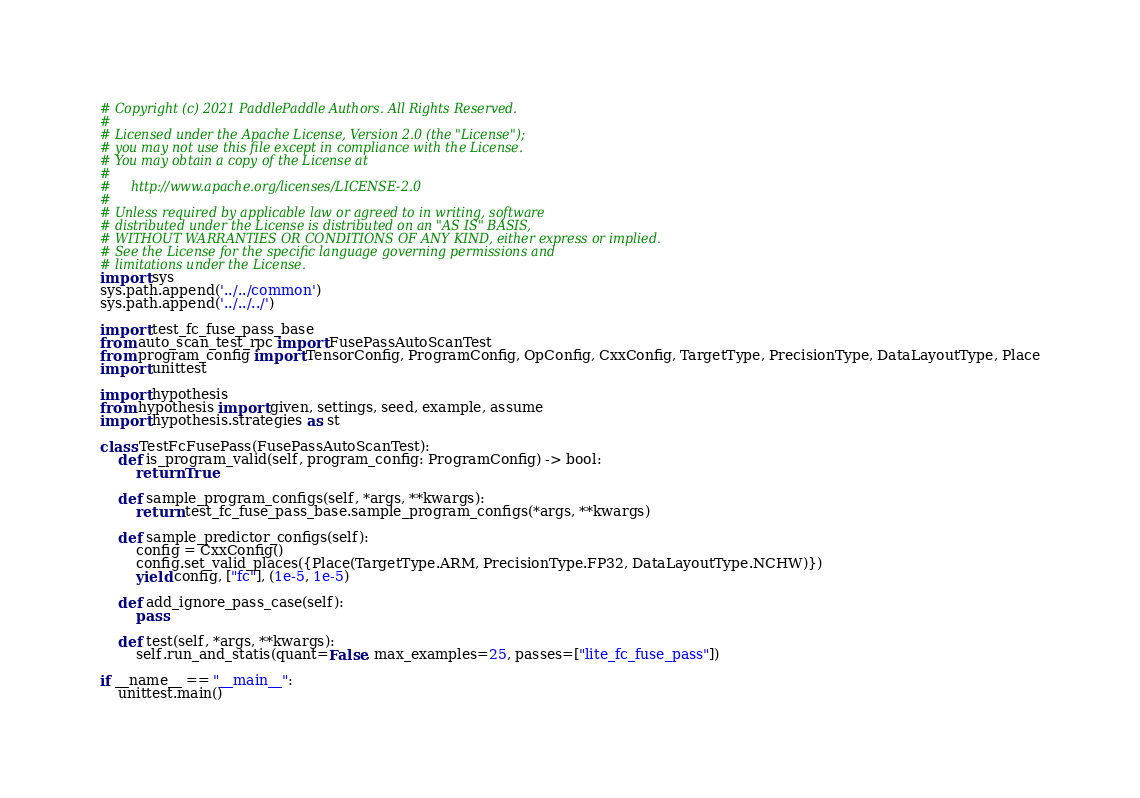Convert code to text. <code><loc_0><loc_0><loc_500><loc_500><_Python_># Copyright (c) 2021 PaddlePaddle Authors. All Rights Reserved.
#
# Licensed under the Apache License, Version 2.0 (the "License");
# you may not use this file except in compliance with the License.
# You may obtain a copy of the License at
#
#     http://www.apache.org/licenses/LICENSE-2.0
#
# Unless required by applicable law or agreed to in writing, software
# distributed under the License is distributed on an "AS IS" BASIS,
# WITHOUT WARRANTIES OR CONDITIONS OF ANY KIND, either express or implied.
# See the License for the specific language governing permissions and
# limitations under the License.
import sys
sys.path.append('../../common')
sys.path.append('../../../')

import test_fc_fuse_pass_base
from auto_scan_test_rpc import FusePassAutoScanTest
from program_config import TensorConfig, ProgramConfig, OpConfig, CxxConfig, TargetType, PrecisionType, DataLayoutType, Place
import unittest

import hypothesis
from hypothesis import given, settings, seed, example, assume
import hypothesis.strategies as st

class TestFcFusePass(FusePassAutoScanTest):
    def is_program_valid(self, program_config: ProgramConfig) -> bool:
        return True

    def sample_program_configs(self, *args, **kwargs):
        return test_fc_fuse_pass_base.sample_program_configs(*args, **kwargs)

    def sample_predictor_configs(self):
        config = CxxConfig()
        config.set_valid_places({Place(TargetType.ARM, PrecisionType.FP32, DataLayoutType.NCHW)})
        yield config, ["fc"], (1e-5, 1e-5)

    def add_ignore_pass_case(self):
        pass

    def test(self, *args, **kwargs):
        self.run_and_statis(quant=False, max_examples=25, passes=["lite_fc_fuse_pass"])

if __name__ == "__main__":
    unittest.main()
</code> 